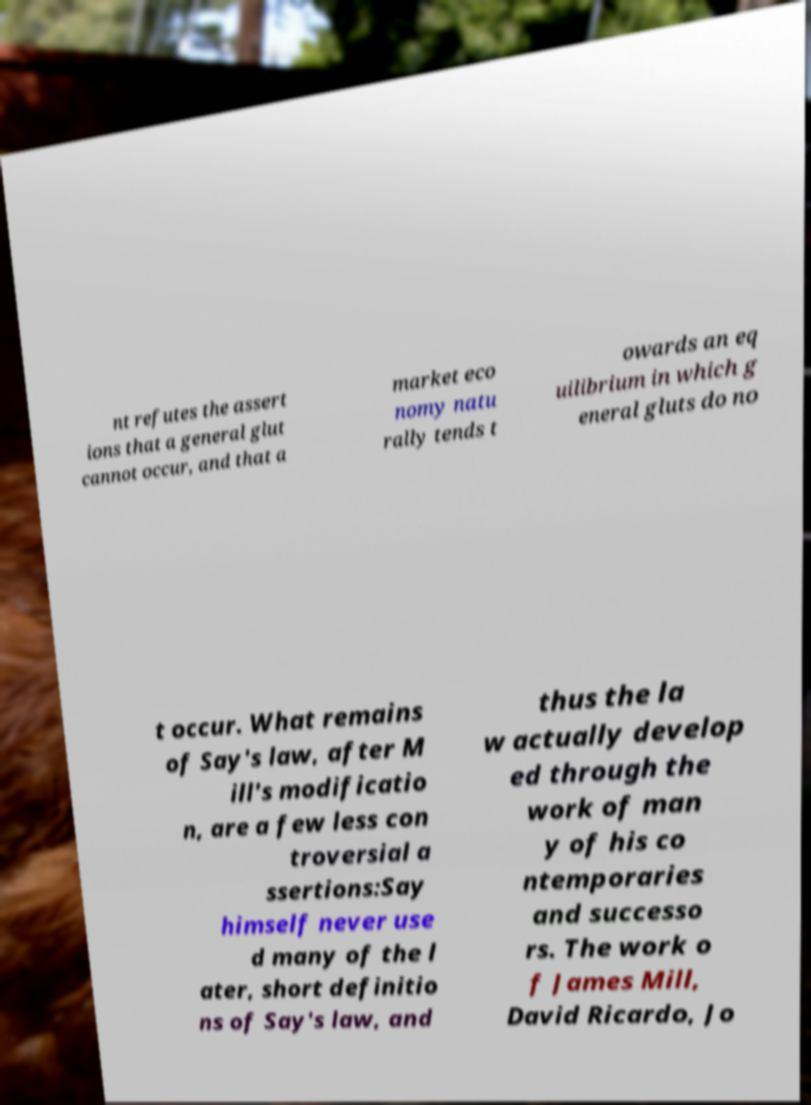Please read and relay the text visible in this image. What does it say? nt refutes the assert ions that a general glut cannot occur, and that a market eco nomy natu rally tends t owards an eq uilibrium in which g eneral gluts do no t occur. What remains of Say's law, after M ill's modificatio n, are a few less con troversial a ssertions:Say himself never use d many of the l ater, short definitio ns of Say's law, and thus the la w actually develop ed through the work of man y of his co ntemporaries and successo rs. The work o f James Mill, David Ricardo, Jo 